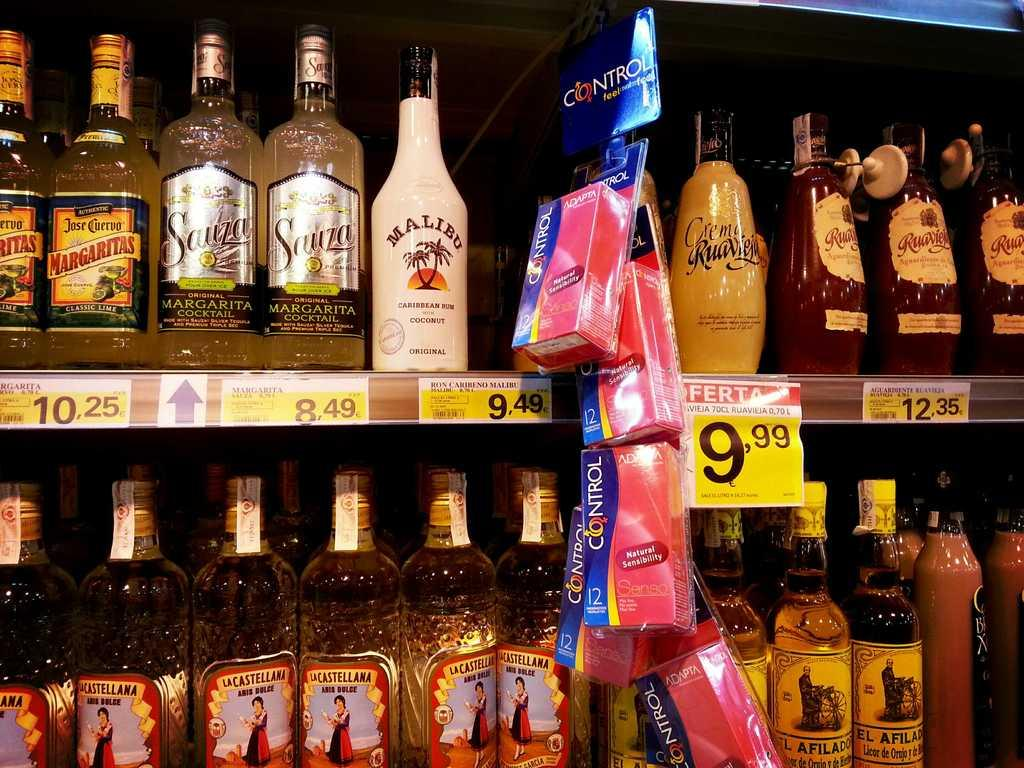<image>
Summarize the visual content of the image. several types of margaritas, rum, other alochol and hanging display of control brand condoms 